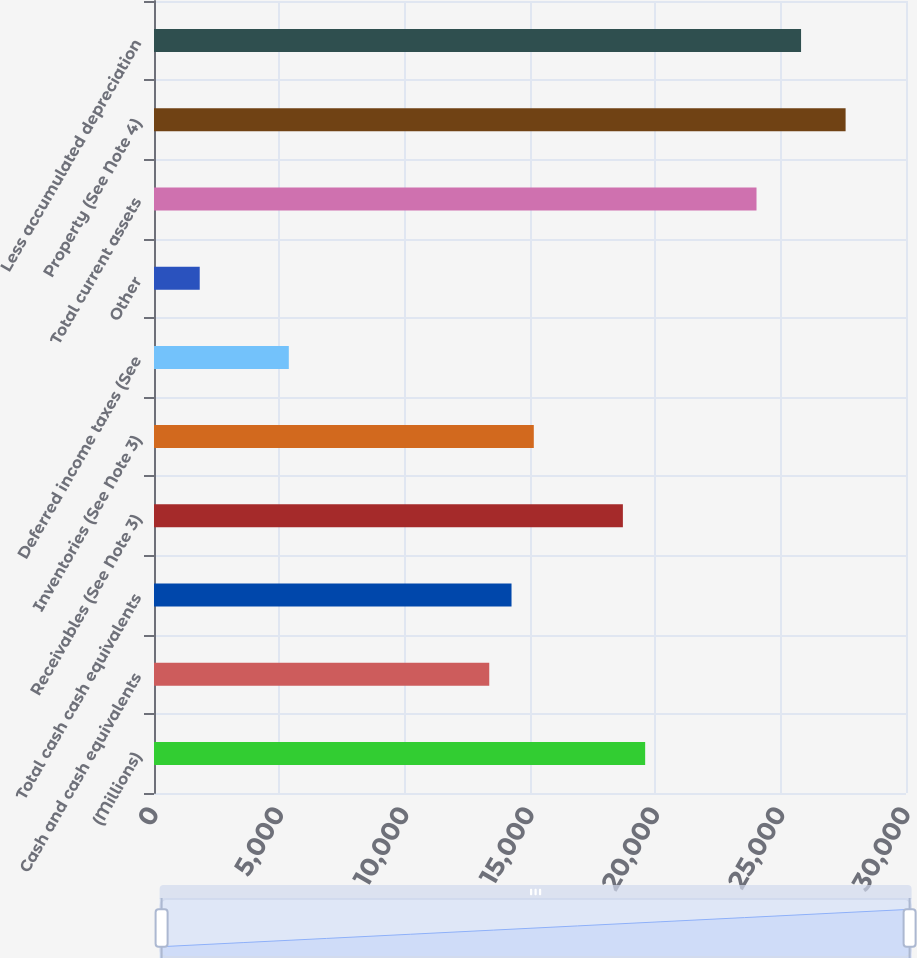Convert chart. <chart><loc_0><loc_0><loc_500><loc_500><bar_chart><fcel>(Millions)<fcel>Cash and cash equivalents<fcel>Total cash cash equivalents<fcel>Receivables (See Note 3)<fcel>Inventories (See Note 3)<fcel>Deferred income taxes (See<fcel>Other<fcel>Total current assets<fcel>Property (See Note 4)<fcel>Less accumulated depreciation<nl><fcel>19594<fcel>13374.5<fcel>14263<fcel>18705.5<fcel>15151.5<fcel>5378<fcel>1824<fcel>24036.5<fcel>27590.5<fcel>25813.5<nl></chart> 